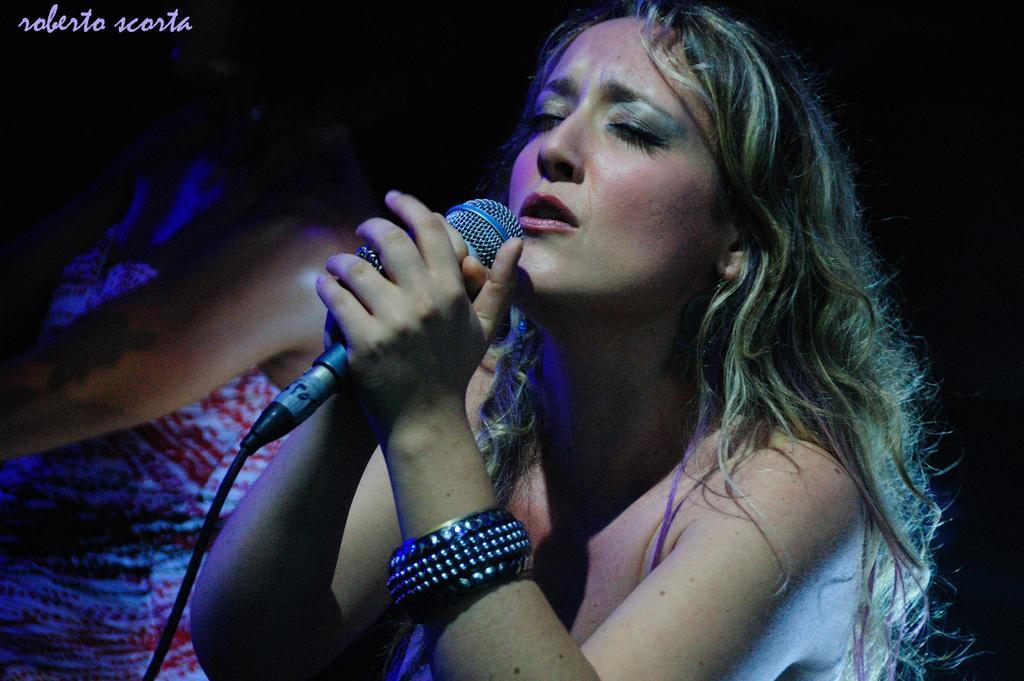Can you describe this image briefly? This picture describes about group of people, in the middle of the image a woman is singing with the help of the microphone. 